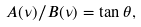Convert formula to latex. <formula><loc_0><loc_0><loc_500><loc_500>A ( \nu ) / B ( \nu ) = \tan \theta ,</formula> 